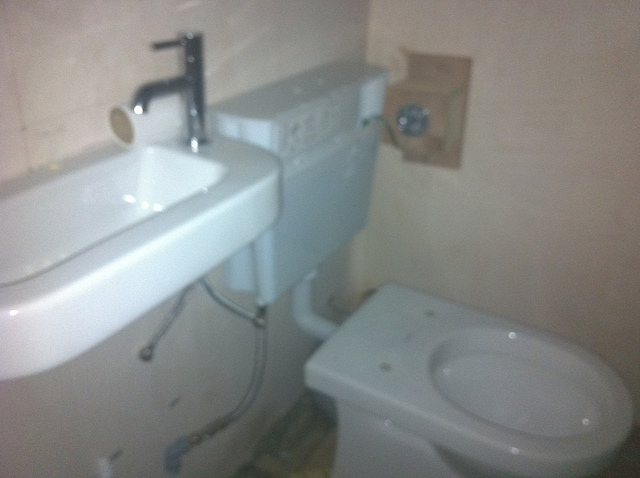Can you estimate the size of this bathroom? Based on the proportion of the fixtures and the angle of the photo, the bathroom seems to be quite compact, perhaps a small guest or half-bath. Does the bathroom have any windows? No windows are visible in the image, which suggests this bathroom relies on artificial lighting. 